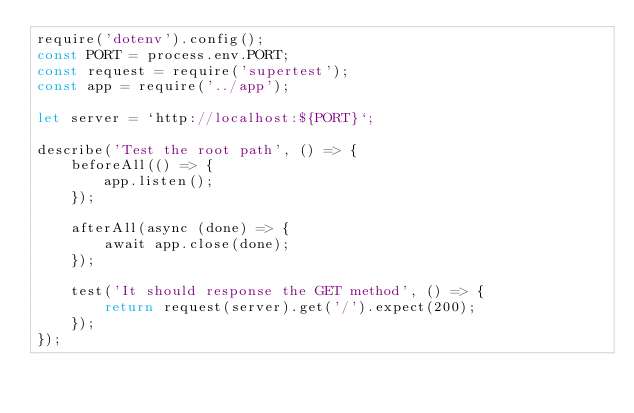Convert code to text. <code><loc_0><loc_0><loc_500><loc_500><_JavaScript_>require('dotenv').config();
const PORT = process.env.PORT;
const request = require('supertest');
const app = require('../app');

let server = `http://localhost:${PORT}`;

describe('Test the root path', () => {
    beforeAll(() => {
        app.listen();
    });

    afterAll(async (done) => {
        await app.close(done);
    });

    test('It should response the GET method', () => {
        return request(server).get('/').expect(200);
    });
});</code> 